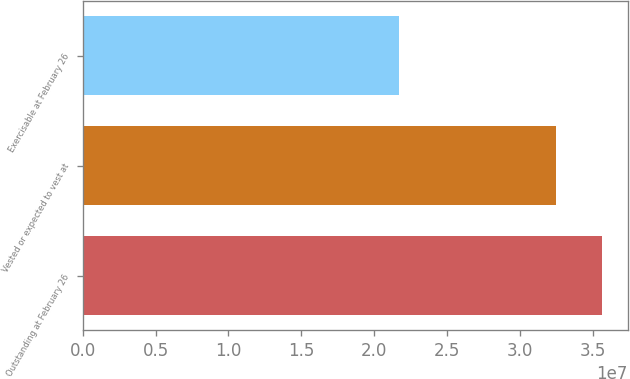<chart> <loc_0><loc_0><loc_500><loc_500><bar_chart><fcel>Outstanding at February 26<fcel>Vested or expected to vest at<fcel>Exercisable at February 26<nl><fcel>3.5587e+07<fcel>3.2438e+07<fcel>2.1717e+07<nl></chart> 